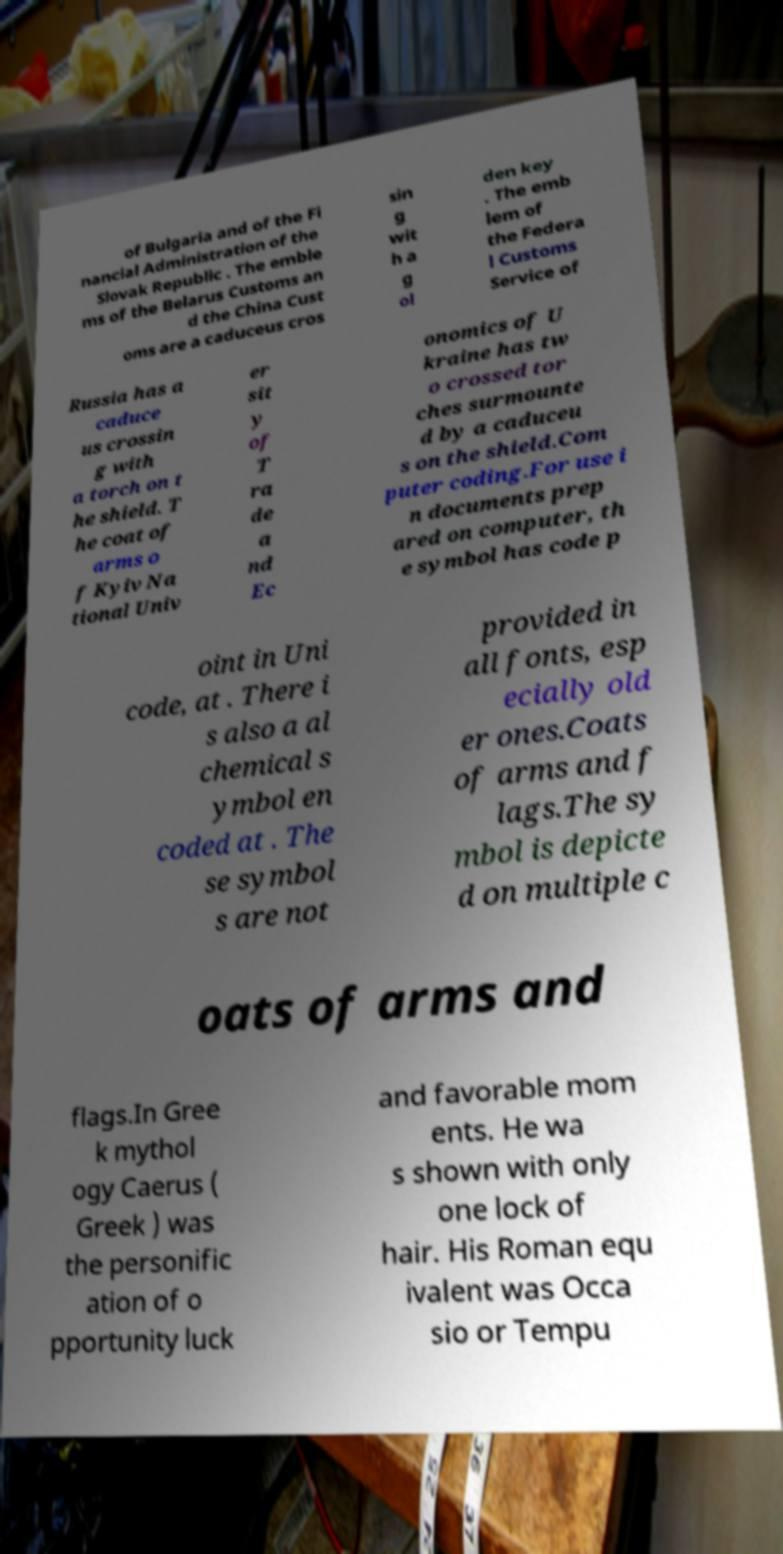For documentation purposes, I need the text within this image transcribed. Could you provide that? of Bulgaria and of the Fi nancial Administration of the Slovak Republic . The emble ms of the Belarus Customs an d the China Cust oms are a caduceus cros sin g wit h a g ol den key . The emb lem of the Federa l Customs Service of Russia has a caduce us crossin g with a torch on t he shield. T he coat of arms o f Kyiv Na tional Univ er sit y of T ra de a nd Ec onomics of U kraine has tw o crossed tor ches surmounte d by a caduceu s on the shield.Com puter coding.For use i n documents prep ared on computer, th e symbol has code p oint in Uni code, at . There i s also a al chemical s ymbol en coded at . The se symbol s are not provided in all fonts, esp ecially old er ones.Coats of arms and f lags.The sy mbol is depicte d on multiple c oats of arms and flags.In Gree k mythol ogy Caerus ( Greek ) was the personific ation of o pportunity luck and favorable mom ents. He wa s shown with only one lock of hair. His Roman equ ivalent was Occa sio or Tempu 